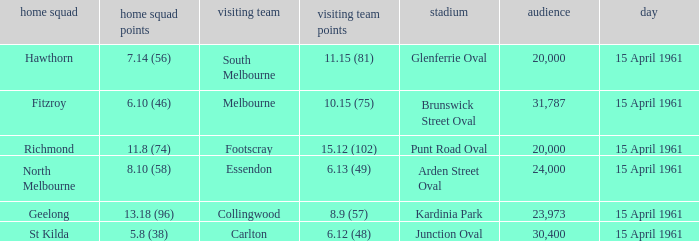What was the score for the home team St Kilda? 5.8 (38). Write the full table. {'header': ['home squad', 'home squad points', 'visiting team', 'visiting team points', 'stadium', 'audience', 'day'], 'rows': [['Hawthorn', '7.14 (56)', 'South Melbourne', '11.15 (81)', 'Glenferrie Oval', '20,000', '15 April 1961'], ['Fitzroy', '6.10 (46)', 'Melbourne', '10.15 (75)', 'Brunswick Street Oval', '31,787', '15 April 1961'], ['Richmond', '11.8 (74)', 'Footscray', '15.12 (102)', 'Punt Road Oval', '20,000', '15 April 1961'], ['North Melbourne', '8.10 (58)', 'Essendon', '6.13 (49)', 'Arden Street Oval', '24,000', '15 April 1961'], ['Geelong', '13.18 (96)', 'Collingwood', '8.9 (57)', 'Kardinia Park', '23,973', '15 April 1961'], ['St Kilda', '5.8 (38)', 'Carlton', '6.12 (48)', 'Junction Oval', '30,400', '15 April 1961']]} 